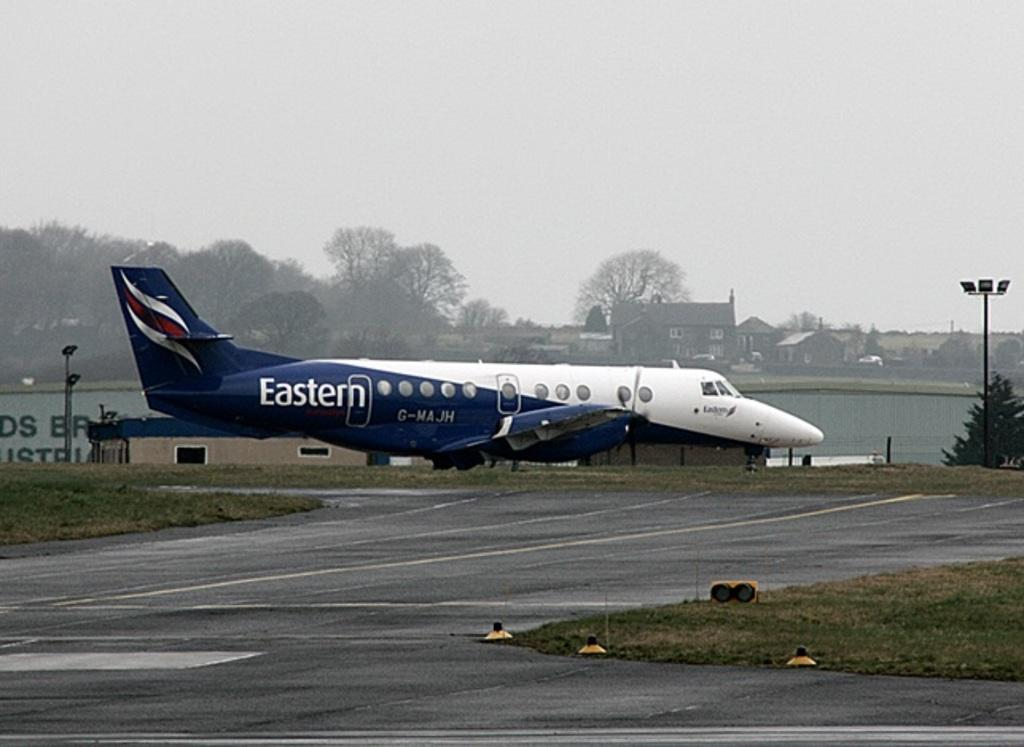<image>
Share a concise interpretation of the image provided. A blue and white plane has the word Eastern near its tail 